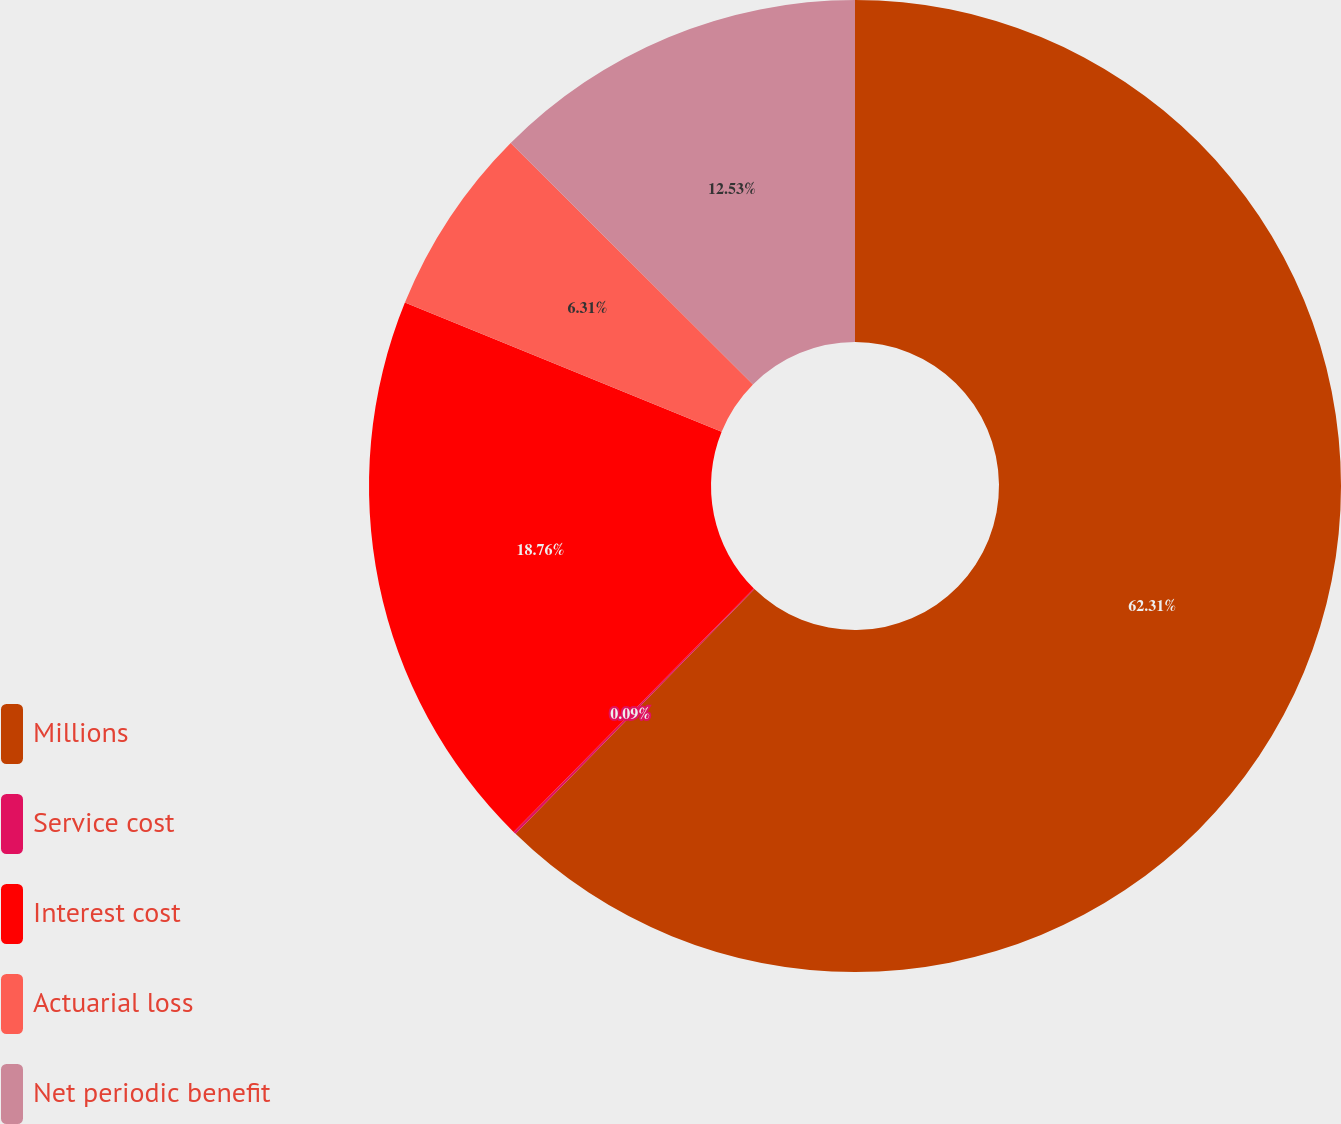<chart> <loc_0><loc_0><loc_500><loc_500><pie_chart><fcel>Millions<fcel>Service cost<fcel>Interest cost<fcel>Actuarial loss<fcel>Net periodic benefit<nl><fcel>62.3%<fcel>0.09%<fcel>18.76%<fcel>6.31%<fcel>12.53%<nl></chart> 